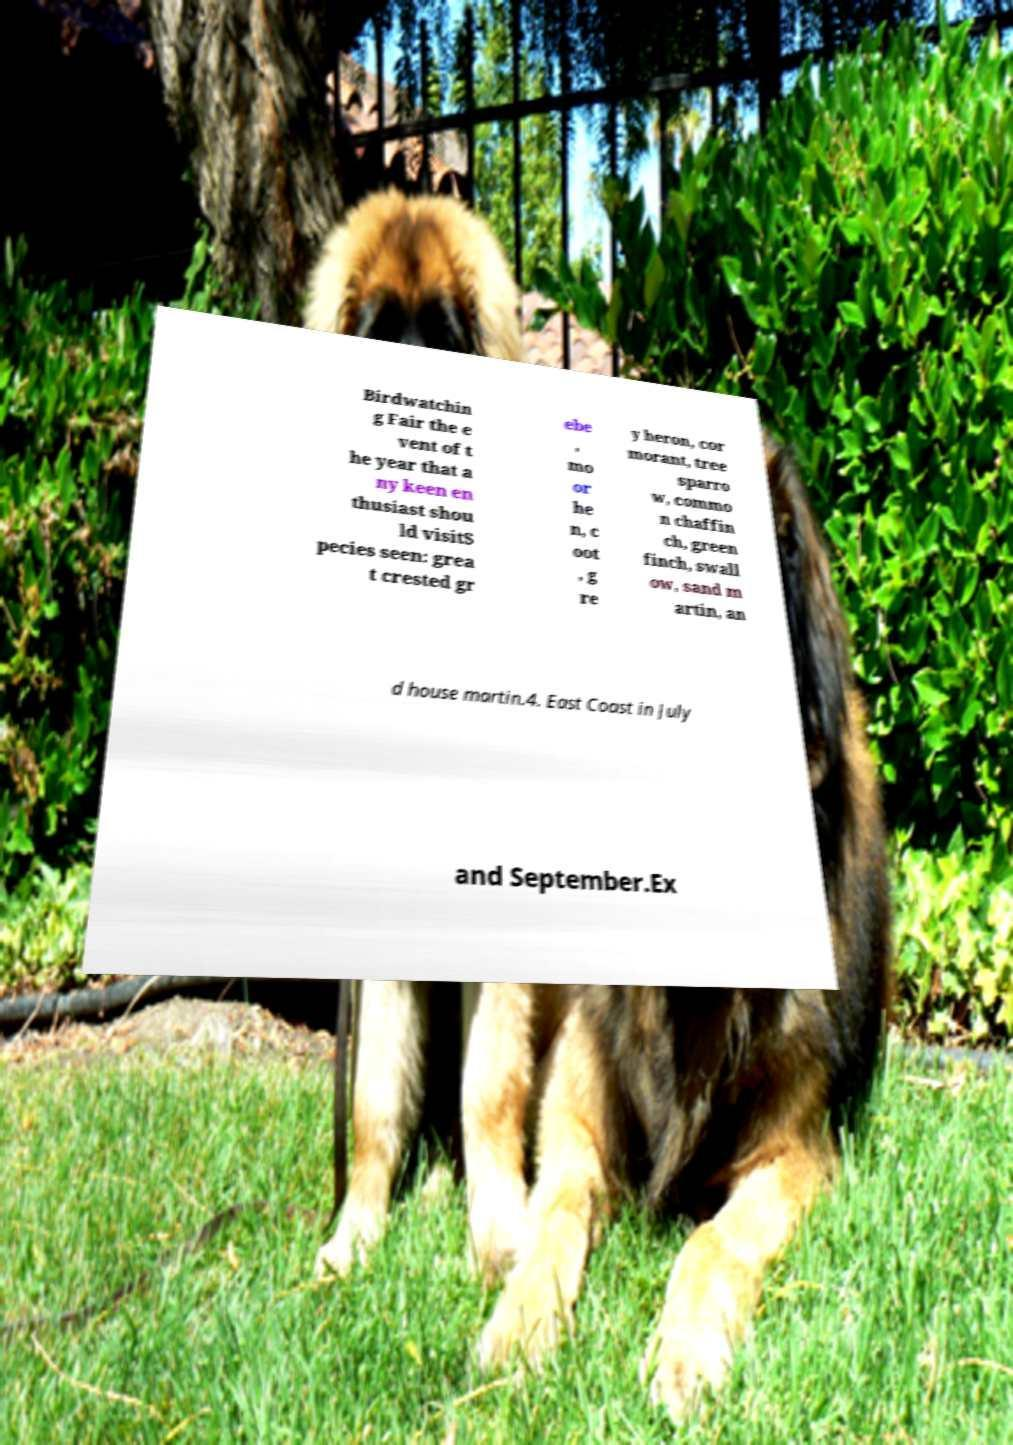What messages or text are displayed in this image? I need them in a readable, typed format. Birdwatchin g Fair the e vent of t he year that a ny keen en thusiast shou ld visitS pecies seen: grea t crested gr ebe , mo or he n, c oot , g re y heron, cor morant, tree sparro w, commo n chaffin ch, green finch, swall ow, sand m artin, an d house martin.4. East Coast in July and September.Ex 